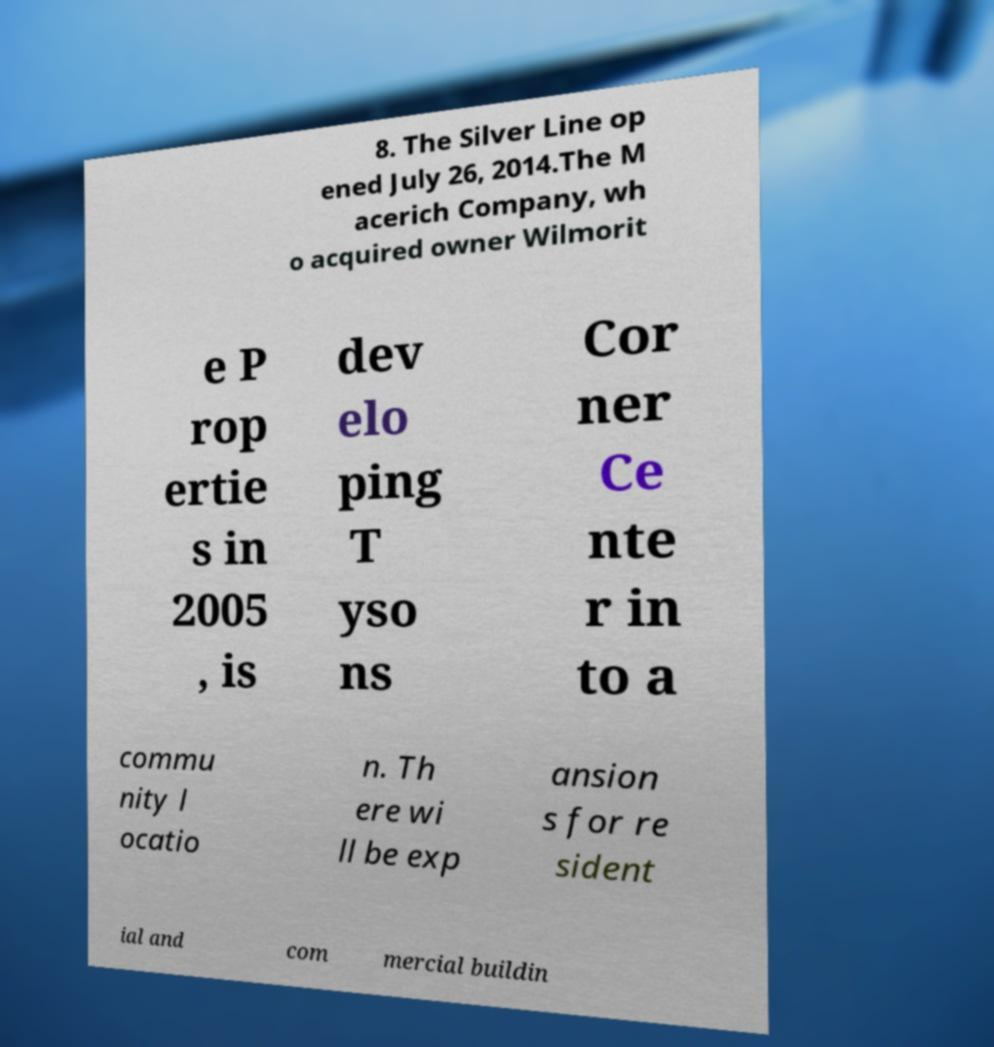Can you accurately transcribe the text from the provided image for me? 8. The Silver Line op ened July 26, 2014.The M acerich Company, wh o acquired owner Wilmorit e P rop ertie s in 2005 , is dev elo ping T yso ns Cor ner Ce nte r in to a commu nity l ocatio n. Th ere wi ll be exp ansion s for re sident ial and com mercial buildin 